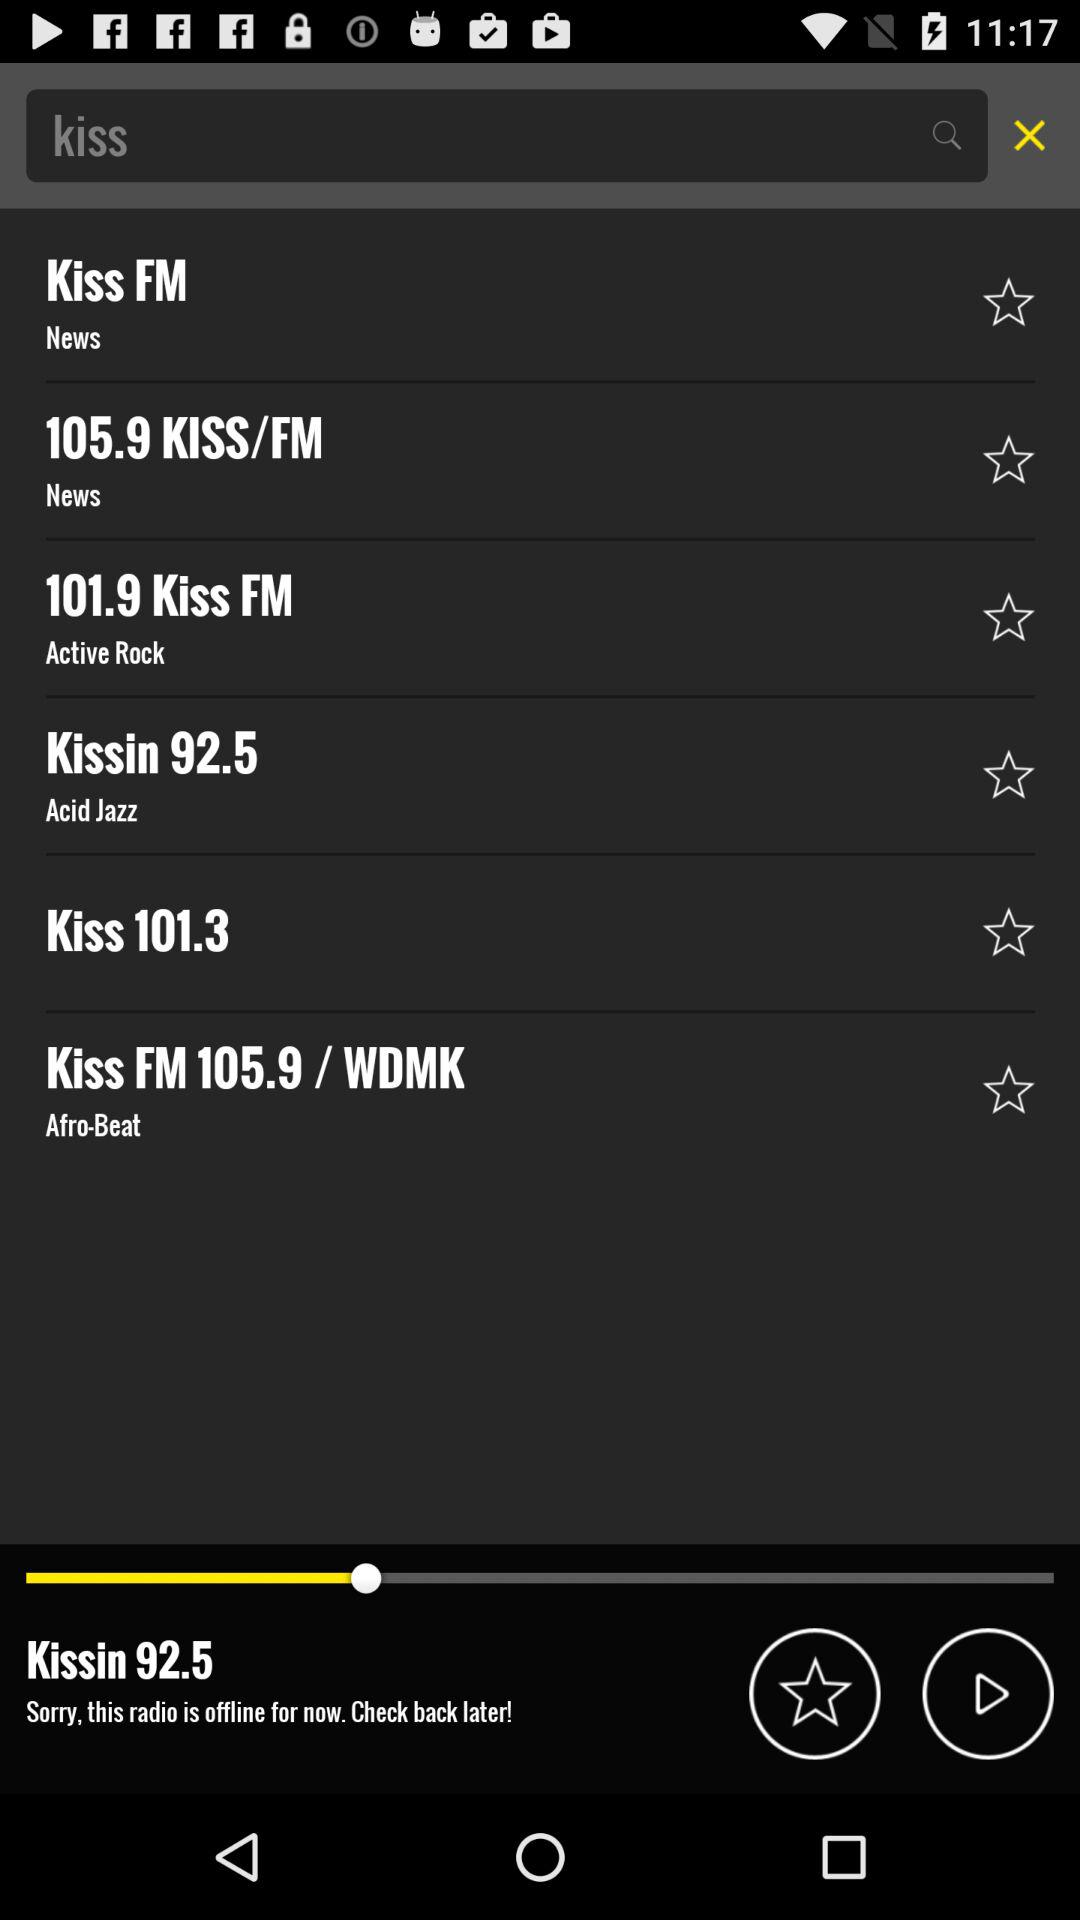Which FM is playing now? The FM which is playing now is "Kissin 92.5". 